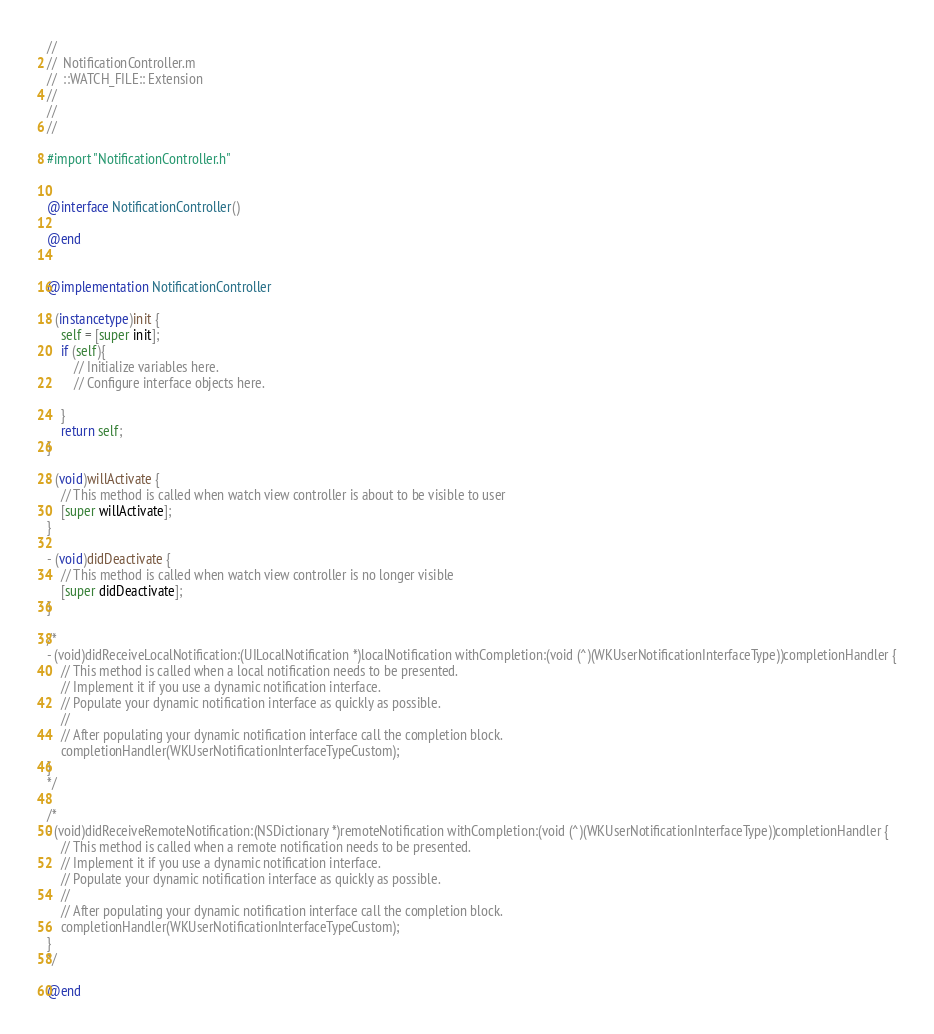<code> <loc_0><loc_0><loc_500><loc_500><_ObjectiveC_>//
//  NotificationController.m
//  ::WATCH_FILE:: Extension
//
//
//

#import "NotificationController.h"


@interface NotificationController()

@end


@implementation NotificationController

- (instancetype)init {
    self = [super init];
    if (self){
        // Initialize variables here.
        // Configure interface objects here.
        
    }
    return self;
}

- (void)willActivate {
    // This method is called when watch view controller is about to be visible to user
    [super willActivate];
}

- (void)didDeactivate {
    // This method is called when watch view controller is no longer visible
    [super didDeactivate];
}

/*
- (void)didReceiveLocalNotification:(UILocalNotification *)localNotification withCompletion:(void (^)(WKUserNotificationInterfaceType))completionHandler {
    // This method is called when a local notification needs to be presented.
    // Implement it if you use a dynamic notification interface.
    // Populate your dynamic notification interface as quickly as possible.
    //
    // After populating your dynamic notification interface call the completion block.
    completionHandler(WKUserNotificationInterfaceTypeCustom);
}
*/

/*
- (void)didReceiveRemoteNotification:(NSDictionary *)remoteNotification withCompletion:(void (^)(WKUserNotificationInterfaceType))completionHandler {
    // This method is called when a remote notification needs to be presented.
    // Implement it if you use a dynamic notification interface.
    // Populate your dynamic notification interface as quickly as possible.
    //
    // After populating your dynamic notification interface call the completion block.
    completionHandler(WKUserNotificationInterfaceTypeCustom);
}
*/

@end



</code> 